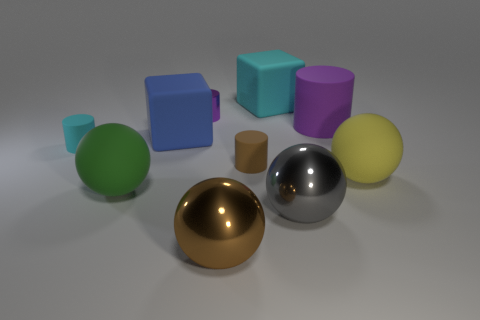What shape is the rubber thing that is the same color as the shiny cylinder?
Offer a very short reply. Cylinder. What size is the object that is the same color as the big cylinder?
Your response must be concise. Small. There is a large cube left of the metal cylinder; what is its material?
Your response must be concise. Rubber. Are there the same number of tiny metal cylinders in front of the large yellow rubber object and big balls?
Offer a very short reply. No. Are there any other things that have the same size as the green object?
Keep it short and to the point. Yes. What material is the purple cylinder that is to the right of the brown rubber cylinder that is behind the yellow thing made of?
Provide a succinct answer. Rubber. What is the shape of the object that is both behind the big blue rubber block and left of the cyan rubber block?
Give a very brief answer. Cylinder. There is another matte thing that is the same shape as the blue rubber thing; what size is it?
Give a very brief answer. Large. Is the number of tiny objects on the left side of the purple matte object less than the number of large metal spheres?
Offer a very short reply. No. There is a cyan thing in front of the large blue matte cube; how big is it?
Provide a succinct answer. Small. 